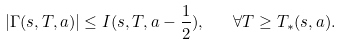Convert formula to latex. <formula><loc_0><loc_0><loc_500><loc_500>| \Gamma ( s , T , a ) | \leq I ( s , T , a - \frac { 1 } { 2 } ) , \quad \forall T \geq T _ { * } ( s , a ) .</formula> 